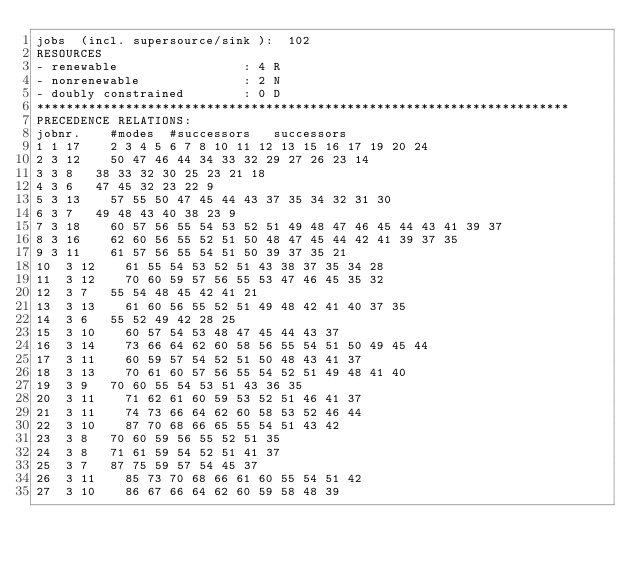<code> <loc_0><loc_0><loc_500><loc_500><_ObjectiveC_>jobs  (incl. supersource/sink ):	102
RESOURCES
- renewable                 : 4 R
- nonrenewable              : 2 N
- doubly constrained        : 0 D
************************************************************************
PRECEDENCE RELATIONS:
jobnr.    #modes  #successors   successors
1	1	17		2 3 4 5 6 7 8 10 11 12 13 15 16 17 19 20 24 
2	3	12		50 47 46 44 34 33 32 29 27 26 23 14 
3	3	8		38 33 32 30 25 23 21 18 
4	3	6		47 45 32 23 22 9 
5	3	13		57 55 50 47 45 44 43 37 35 34 32 31 30 
6	3	7		49 48 43 40 38 23 9 
7	3	18		60 57 56 55 54 53 52 51 49 48 47 46 45 44 43 41 39 37 
8	3	16		62 60 56 55 52 51 50 48 47 45 44 42 41 39 37 35 
9	3	11		61 57 56 55 54 51 50 39 37 35 21 
10	3	12		61 55 54 53 52 51 43 38 37 35 34 28 
11	3	12		70 60 59 57 56 55 53 47 46 45 35 32 
12	3	7		55 54 48 45 42 41 21 
13	3	13		61 60 56 55 52 51 49 48 42 41 40 37 35 
14	3	6		55 52 49 42 28 25 
15	3	10		60 57 54 53 48 47 45 44 43 37 
16	3	14		73 66 64 62 60 58 56 55 54 51 50 49 45 44 
17	3	11		60 59 57 54 52 51 50 48 43 41 37 
18	3	13		70 61 60 57 56 55 54 52 51 49 48 41 40 
19	3	9		70 60 55 54 53 51 43 36 35 
20	3	11		71 62 61 60 59 53 52 51 46 41 37 
21	3	11		74 73 66 64 62 60 58 53 52 46 44 
22	3	10		87 70 68 66 65 55 54 51 43 42 
23	3	8		70 60 59 56 55 52 51 35 
24	3	8		71 61 59 54 52 51 41 37 
25	3	7		87 75 59 57 54 45 37 
26	3	11		85 73 70 68 66 61 60 55 54 51 42 
27	3	10		86 67 66 64 62 60 59 58 48 39 </code> 